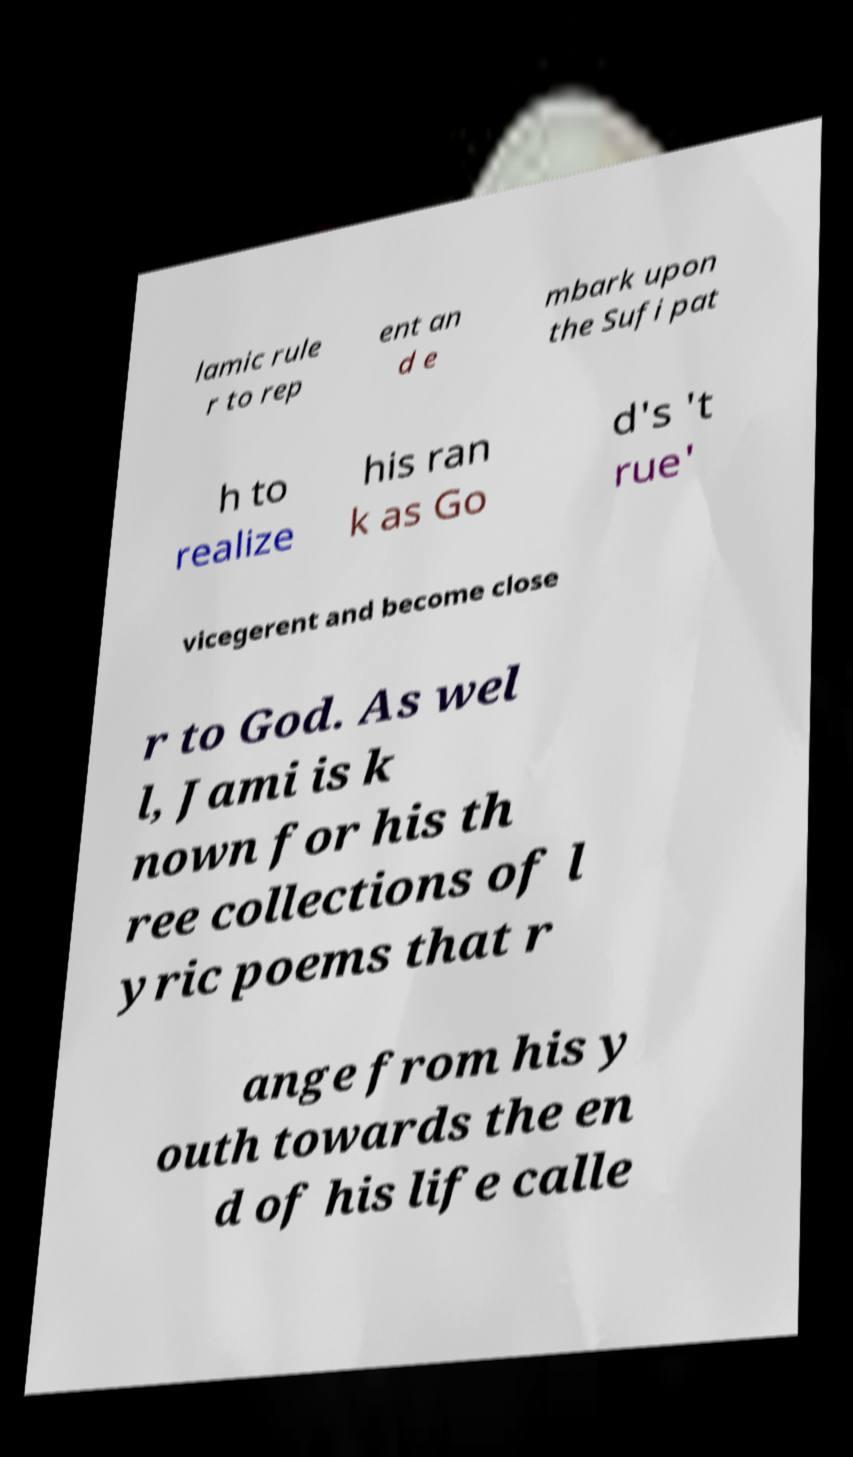Could you assist in decoding the text presented in this image and type it out clearly? lamic rule r to rep ent an d e mbark upon the Sufi pat h to realize his ran k as Go d's 't rue' vicegerent and become close r to God. As wel l, Jami is k nown for his th ree collections of l yric poems that r ange from his y outh towards the en d of his life calle 